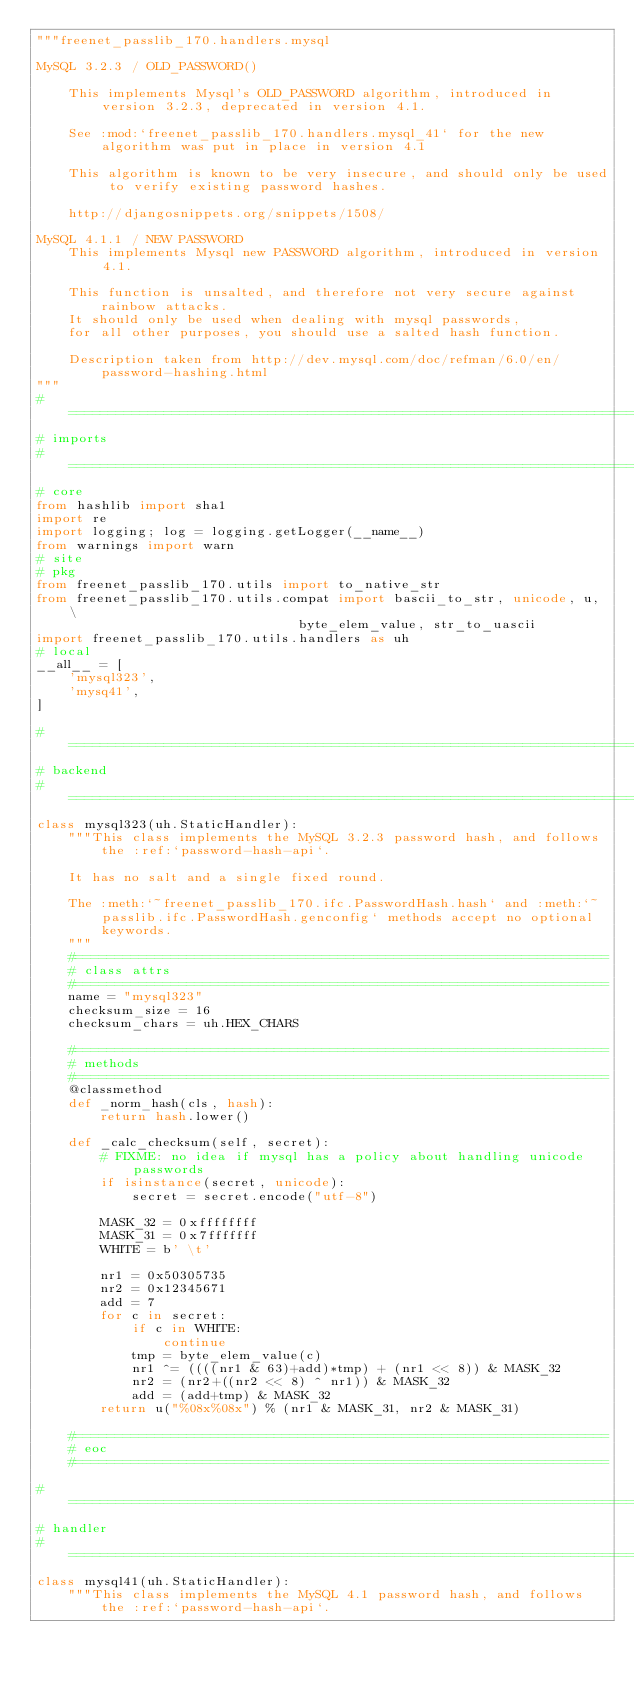Convert code to text. <code><loc_0><loc_0><loc_500><loc_500><_Python_>"""freenet_passlib_170.handlers.mysql

MySQL 3.2.3 / OLD_PASSWORD()

    This implements Mysql's OLD_PASSWORD algorithm, introduced in version 3.2.3, deprecated in version 4.1.

    See :mod:`freenet_passlib_170.handlers.mysql_41` for the new algorithm was put in place in version 4.1

    This algorithm is known to be very insecure, and should only be used to verify existing password hashes.

    http://djangosnippets.org/snippets/1508/

MySQL 4.1.1 / NEW PASSWORD
    This implements Mysql new PASSWORD algorithm, introduced in version 4.1.

    This function is unsalted, and therefore not very secure against rainbow attacks.
    It should only be used when dealing with mysql passwords,
    for all other purposes, you should use a salted hash function.

    Description taken from http://dev.mysql.com/doc/refman/6.0/en/password-hashing.html
"""
#=============================================================================
# imports
#=============================================================================
# core
from hashlib import sha1
import re
import logging; log = logging.getLogger(__name__)
from warnings import warn
# site
# pkg
from freenet_passlib_170.utils import to_native_str
from freenet_passlib_170.utils.compat import bascii_to_str, unicode, u, \
                                 byte_elem_value, str_to_uascii
import freenet_passlib_170.utils.handlers as uh
# local
__all__ = [
    'mysql323',
    'mysq41',
]

#=============================================================================
# backend
#=============================================================================
class mysql323(uh.StaticHandler):
    """This class implements the MySQL 3.2.3 password hash, and follows the :ref:`password-hash-api`.

    It has no salt and a single fixed round.

    The :meth:`~freenet_passlib_170.ifc.PasswordHash.hash` and :meth:`~passlib.ifc.PasswordHash.genconfig` methods accept no optional keywords.
    """
    #===================================================================
    # class attrs
    #===================================================================
    name = "mysql323"
    checksum_size = 16
    checksum_chars = uh.HEX_CHARS

    #===================================================================
    # methods
    #===================================================================
    @classmethod
    def _norm_hash(cls, hash):
        return hash.lower()

    def _calc_checksum(self, secret):
        # FIXME: no idea if mysql has a policy about handling unicode passwords
        if isinstance(secret, unicode):
            secret = secret.encode("utf-8")

        MASK_32 = 0xffffffff
        MASK_31 = 0x7fffffff
        WHITE = b' \t'

        nr1 = 0x50305735
        nr2 = 0x12345671
        add = 7
        for c in secret:
            if c in WHITE:
                continue
            tmp = byte_elem_value(c)
            nr1 ^= ((((nr1 & 63)+add)*tmp) + (nr1 << 8)) & MASK_32
            nr2 = (nr2+((nr2 << 8) ^ nr1)) & MASK_32
            add = (add+tmp) & MASK_32
        return u("%08x%08x") % (nr1 & MASK_31, nr2 & MASK_31)

    #===================================================================
    # eoc
    #===================================================================

#=============================================================================
# handler
#=============================================================================
class mysql41(uh.StaticHandler):
    """This class implements the MySQL 4.1 password hash, and follows the :ref:`password-hash-api`.
</code> 